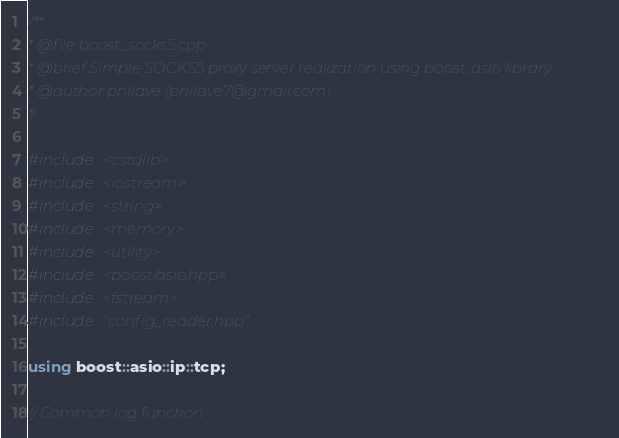<code> <loc_0><loc_0><loc_500><loc_500><_C++_>/**
* @file boost_socks5.cpp
* @brief Simple SOCKS5 proxy server realization using boost::asio library
* @author philave (philave7@gmail.com)
*/

#include <cstdlib>
#include <iostream>
#include <string>
#include <memory>
#include <utility>
#include <boost/asio.hpp>
#include <fstream>
#include "config_reader.hpp"

using boost::asio::ip::tcp;

// Common log function</code> 